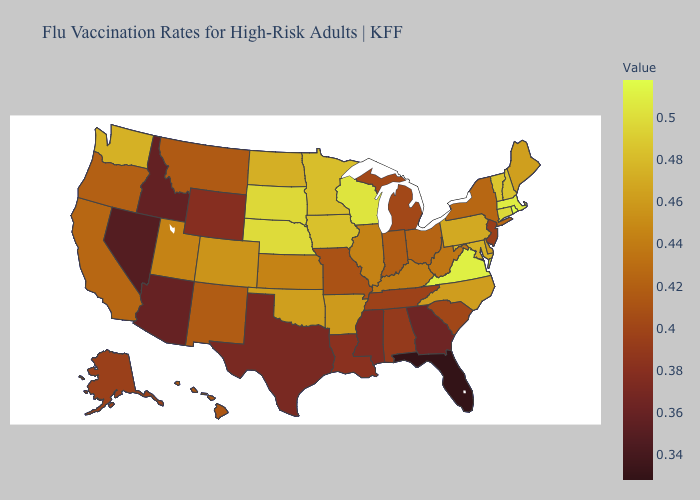Among the states that border Tennessee , which have the highest value?
Quick response, please. Virginia. Does Michigan have the lowest value in the MidWest?
Answer briefly. Yes. Does Florida have the lowest value in the USA?
Quick response, please. Yes. Does the map have missing data?
Concise answer only. No. Does Maryland have a higher value than Michigan?
Short answer required. Yes. 